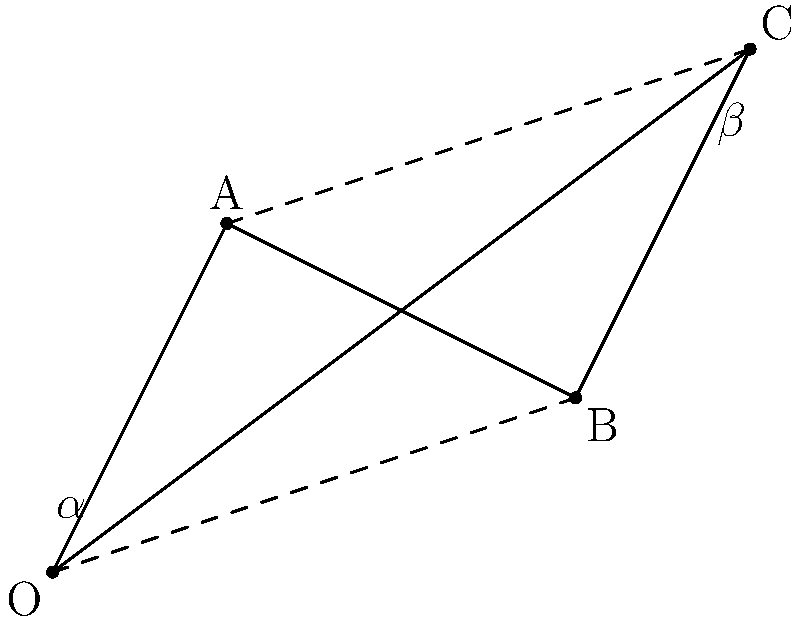Given the suspension geometry diagram above, which represents a simplified comparison between a JDM sports car (triangle OAB) and a German sports car (triangle OBC), calculate the difference in the suspension geometry angle ($\Delta \theta$) between the two designs. Assume $\alpha = 30°$ and $\beta = 45°$. To solve this problem, we need to follow these steps:

1. Identify the suspension geometry angles for each car:
   - JDM sports car: $\angle AOB$
   - German sports car: $\angle BOC$

2. Calculate $\angle AOB$:
   - In triangle OAB, we know $\alpha = 30°$
   - $\angle AOB = 180° - 2\alpha$ (because OAB is isosceles)
   - $\angle AOB = 180° - 2(30°) = 120°$

3. Calculate $\angle BOC$:
   - In triangle OBC, we know $\beta = 45°$
   - $\angle BOC = 180° - 2\beta$ (because OBC is isosceles)
   - $\angle BOC = 180° - 2(45°) = 90°$

4. Calculate the difference in suspension geometry angles:
   $\Delta \theta = \angle AOB - \angle BOC = 120° - 90° = 30°$

Therefore, the difference in suspension geometry angles between the JDM sports car and the German sports car is 30°.
Answer: $30°$ 